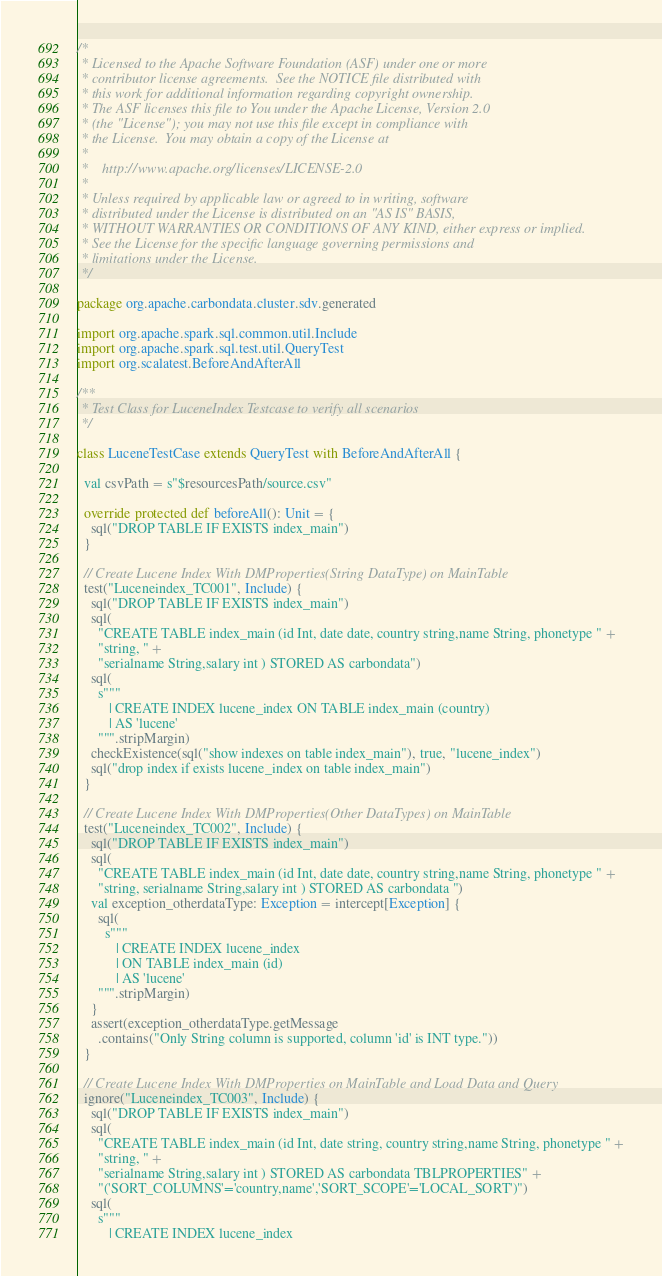Convert code to text. <code><loc_0><loc_0><loc_500><loc_500><_Scala_>/*
 * Licensed to the Apache Software Foundation (ASF) under one or more
 * contributor license agreements.  See the NOTICE file distributed with
 * this work for additional information regarding copyright ownership.
 * The ASF licenses this file to You under the Apache License, Version 2.0
 * (the "License"); you may not use this file except in compliance with
 * the License.  You may obtain a copy of the License at
 *
 *    http://www.apache.org/licenses/LICENSE-2.0
 *
 * Unless required by applicable law or agreed to in writing, software
 * distributed under the License is distributed on an "AS IS" BASIS,
 * WITHOUT WARRANTIES OR CONDITIONS OF ANY KIND, either express or implied.
 * See the License for the specific language governing permissions and
 * limitations under the License.
 */

package org.apache.carbondata.cluster.sdv.generated

import org.apache.spark.sql.common.util.Include
import org.apache.spark.sql.test.util.QueryTest
import org.scalatest.BeforeAndAfterAll

/**
 * Test Class for LuceneIndex Testcase to verify all scenarios
 */

class LuceneTestCase extends QueryTest with BeforeAndAfterAll {

  val csvPath = s"$resourcesPath/source.csv"

  override protected def beforeAll(): Unit = {
    sql("DROP TABLE IF EXISTS index_main")
  }

  // Create Lucene Index With DMProperties(String DataType) on MainTable
  test("Luceneindex_TC001", Include) {
    sql("DROP TABLE IF EXISTS index_main")
    sql(
      "CREATE TABLE index_main (id Int, date date, country string,name String, phonetype " +
      "string, " +
      "serialname String,salary int ) STORED AS carbondata")
    sql(
      s"""
         | CREATE INDEX lucene_index ON TABLE index_main (country)
         | AS 'lucene'
      """.stripMargin)
    checkExistence(sql("show indexes on table index_main"), true, "lucene_index")
    sql("drop index if exists lucene_index on table index_main")
  }

  // Create Lucene Index With DMProperties(Other DataTypes) on MainTable
  test("Luceneindex_TC002", Include) {
    sql("DROP TABLE IF EXISTS index_main")
    sql(
      "CREATE TABLE index_main (id Int, date date, country string,name String, phonetype " +
      "string, serialname String,salary int ) STORED AS carbondata ")
    val exception_otherdataType: Exception = intercept[Exception] {
      sql(
        s"""
           | CREATE INDEX lucene_index
           | ON TABLE index_main (id)
           | AS 'lucene'
      """.stripMargin)
    }
    assert(exception_otherdataType.getMessage
      .contains("Only String column is supported, column 'id' is INT type."))
  }

  // Create Lucene Index With DMProperties on MainTable and Load Data and Query
  ignore("Luceneindex_TC003", Include) {
    sql("DROP TABLE IF EXISTS index_main")
    sql(
      "CREATE TABLE index_main (id Int, date string, country string,name String, phonetype " +
      "string, " +
      "serialname String,salary int ) STORED AS carbondata TBLPROPERTIES" +
      "('SORT_COLUMNS'='country,name','SORT_SCOPE'='LOCAL_SORT')")
    sql(
      s"""
         | CREATE INDEX lucene_index</code> 